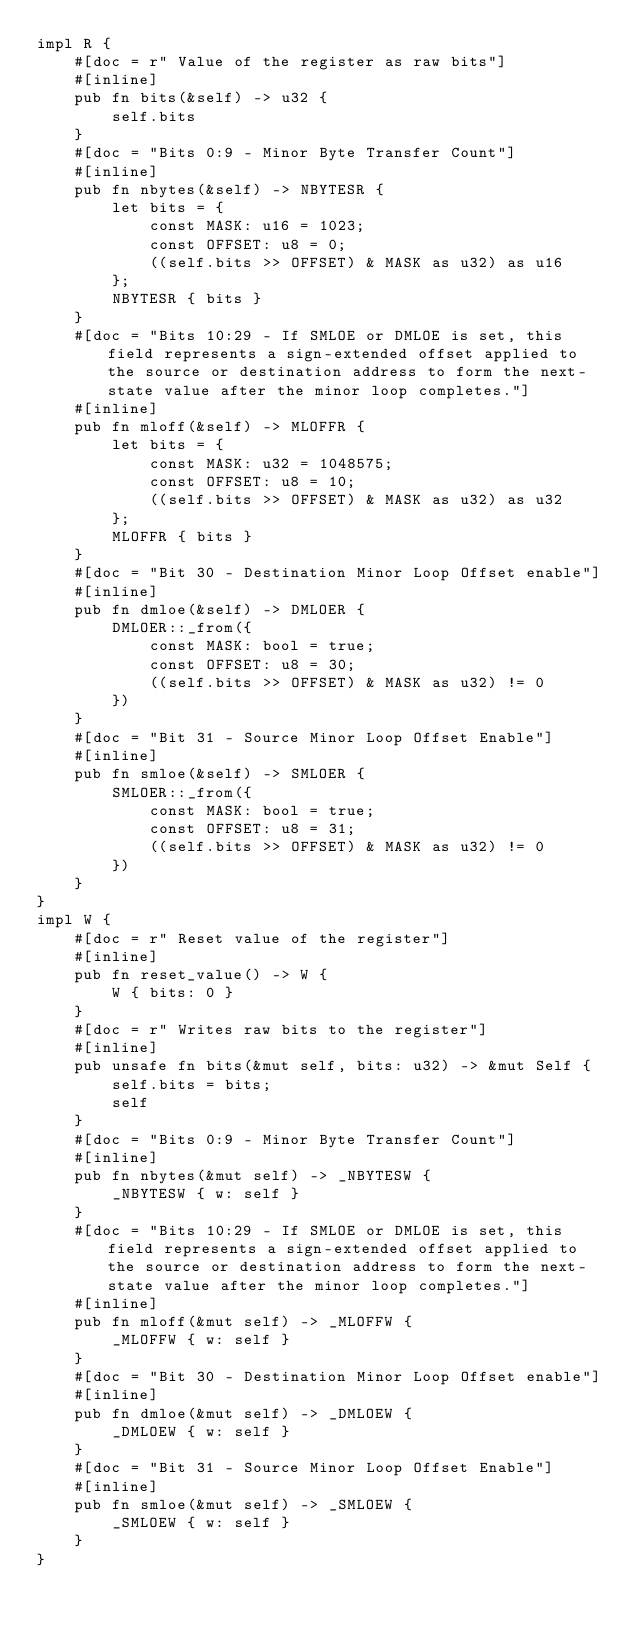<code> <loc_0><loc_0><loc_500><loc_500><_Rust_>impl R {
    #[doc = r" Value of the register as raw bits"]
    #[inline]
    pub fn bits(&self) -> u32 {
        self.bits
    }
    #[doc = "Bits 0:9 - Minor Byte Transfer Count"]
    #[inline]
    pub fn nbytes(&self) -> NBYTESR {
        let bits = {
            const MASK: u16 = 1023;
            const OFFSET: u8 = 0;
            ((self.bits >> OFFSET) & MASK as u32) as u16
        };
        NBYTESR { bits }
    }
    #[doc = "Bits 10:29 - If SMLOE or DMLOE is set, this field represents a sign-extended offset applied to the source or destination address to form the next-state value after the minor loop completes."]
    #[inline]
    pub fn mloff(&self) -> MLOFFR {
        let bits = {
            const MASK: u32 = 1048575;
            const OFFSET: u8 = 10;
            ((self.bits >> OFFSET) & MASK as u32) as u32
        };
        MLOFFR { bits }
    }
    #[doc = "Bit 30 - Destination Minor Loop Offset enable"]
    #[inline]
    pub fn dmloe(&self) -> DMLOER {
        DMLOER::_from({
            const MASK: bool = true;
            const OFFSET: u8 = 30;
            ((self.bits >> OFFSET) & MASK as u32) != 0
        })
    }
    #[doc = "Bit 31 - Source Minor Loop Offset Enable"]
    #[inline]
    pub fn smloe(&self) -> SMLOER {
        SMLOER::_from({
            const MASK: bool = true;
            const OFFSET: u8 = 31;
            ((self.bits >> OFFSET) & MASK as u32) != 0
        })
    }
}
impl W {
    #[doc = r" Reset value of the register"]
    #[inline]
    pub fn reset_value() -> W {
        W { bits: 0 }
    }
    #[doc = r" Writes raw bits to the register"]
    #[inline]
    pub unsafe fn bits(&mut self, bits: u32) -> &mut Self {
        self.bits = bits;
        self
    }
    #[doc = "Bits 0:9 - Minor Byte Transfer Count"]
    #[inline]
    pub fn nbytes(&mut self) -> _NBYTESW {
        _NBYTESW { w: self }
    }
    #[doc = "Bits 10:29 - If SMLOE or DMLOE is set, this field represents a sign-extended offset applied to the source or destination address to form the next-state value after the minor loop completes."]
    #[inline]
    pub fn mloff(&mut self) -> _MLOFFW {
        _MLOFFW { w: self }
    }
    #[doc = "Bit 30 - Destination Minor Loop Offset enable"]
    #[inline]
    pub fn dmloe(&mut self) -> _DMLOEW {
        _DMLOEW { w: self }
    }
    #[doc = "Bit 31 - Source Minor Loop Offset Enable"]
    #[inline]
    pub fn smloe(&mut self) -> _SMLOEW {
        _SMLOEW { w: self }
    }
}
</code> 